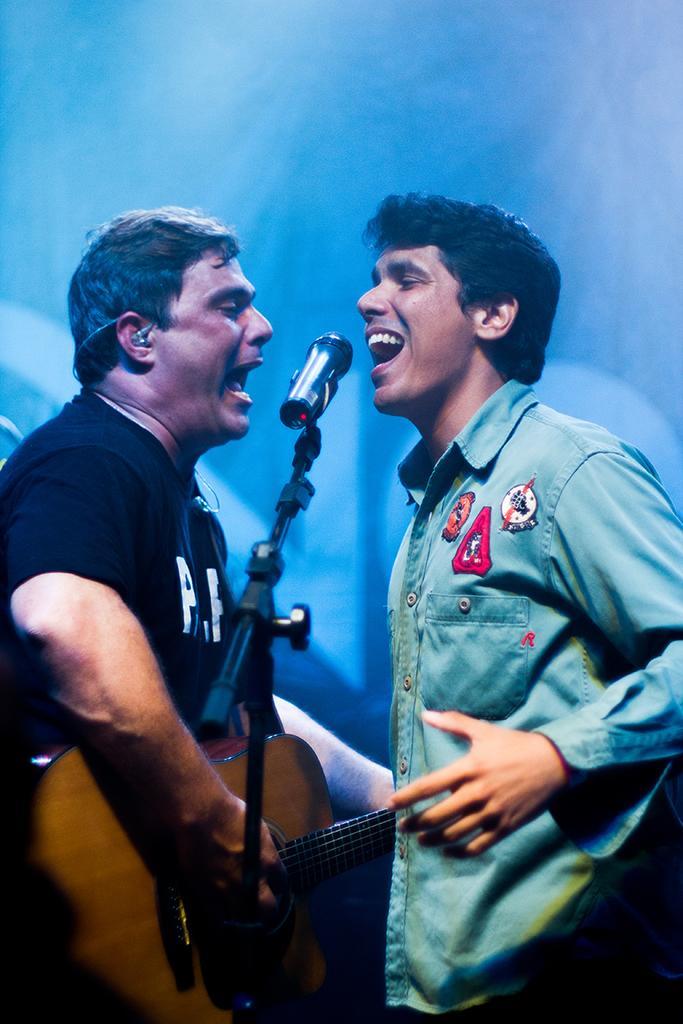Describe this image in one or two sentences. In this image I see 2 men who are standing in front of a mic and this man over here is holding the guitar. 